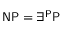<formula> <loc_0><loc_0><loc_500><loc_500>{ N P } = \exists ^ { P } { P }</formula> 